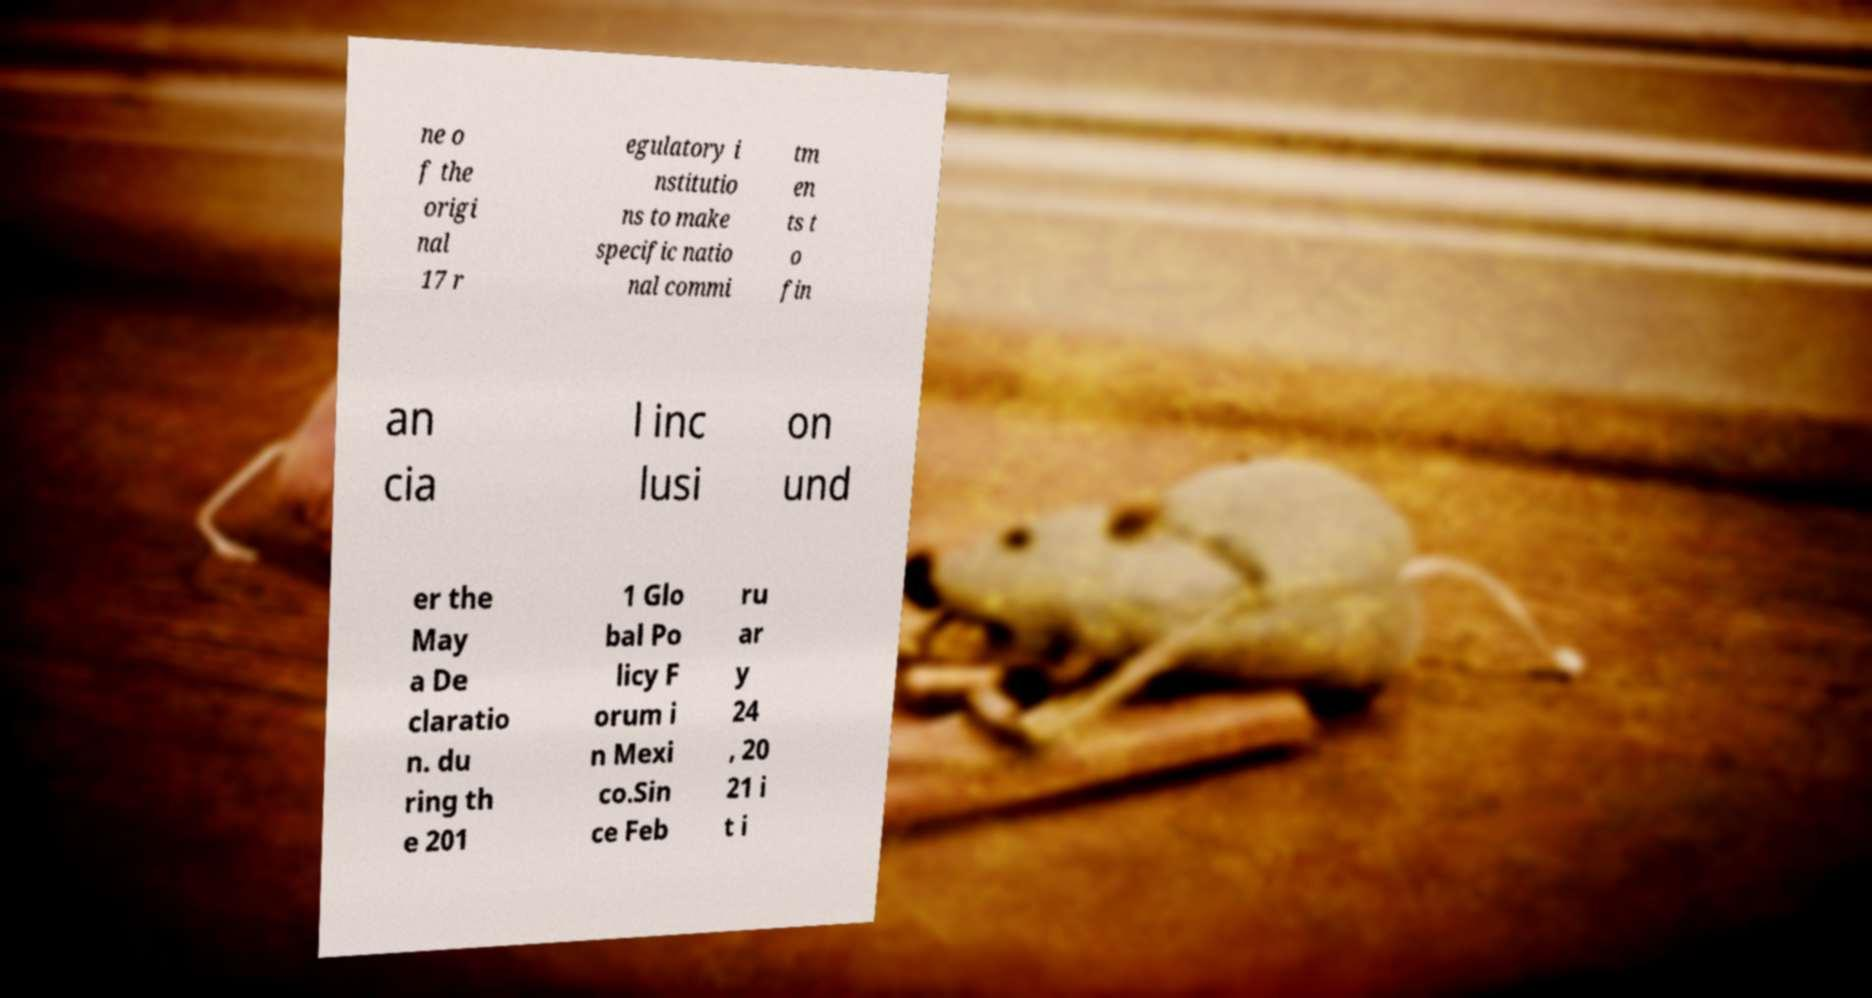I need the written content from this picture converted into text. Can you do that? ne o f the origi nal 17 r egulatory i nstitutio ns to make specific natio nal commi tm en ts t o fin an cia l inc lusi on und er the May a De claratio n. du ring th e 201 1 Glo bal Po licy F orum i n Mexi co.Sin ce Feb ru ar y 24 , 20 21 i t i 